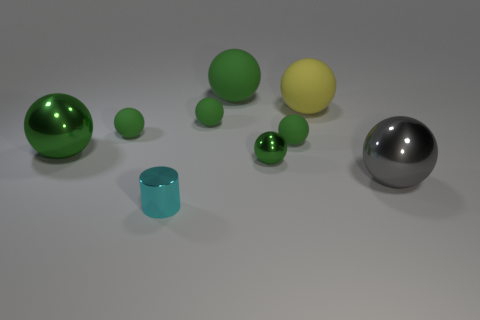Subtract all green spheres. How many were subtracted if there are4green spheres left? 2 Subtract all small rubber balls. How many balls are left? 5 Subtract all gray balls. How many balls are left? 7 Subtract all cylinders. How many objects are left? 8 Subtract 1 spheres. How many spheres are left? 7 Subtract all large yellow rubber objects. Subtract all large green rubber spheres. How many objects are left? 7 Add 2 tiny cyan metal objects. How many tiny cyan metal objects are left? 3 Add 4 big yellow balls. How many big yellow balls exist? 5 Subtract 1 gray balls. How many objects are left? 8 Subtract all blue spheres. Subtract all red blocks. How many spheres are left? 8 